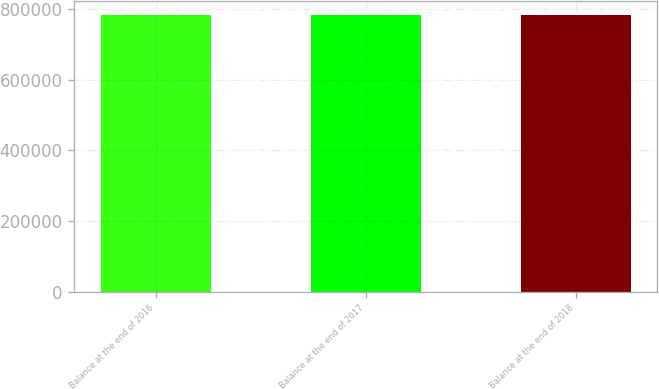Convert chart. <chart><loc_0><loc_0><loc_500><loc_500><bar_chart><fcel>Balance at the end of 2016<fcel>Balance at the end of 2017<fcel>Balance at the end of 2018<nl><fcel>782664<fcel>782664<fcel>782664<nl></chart> 